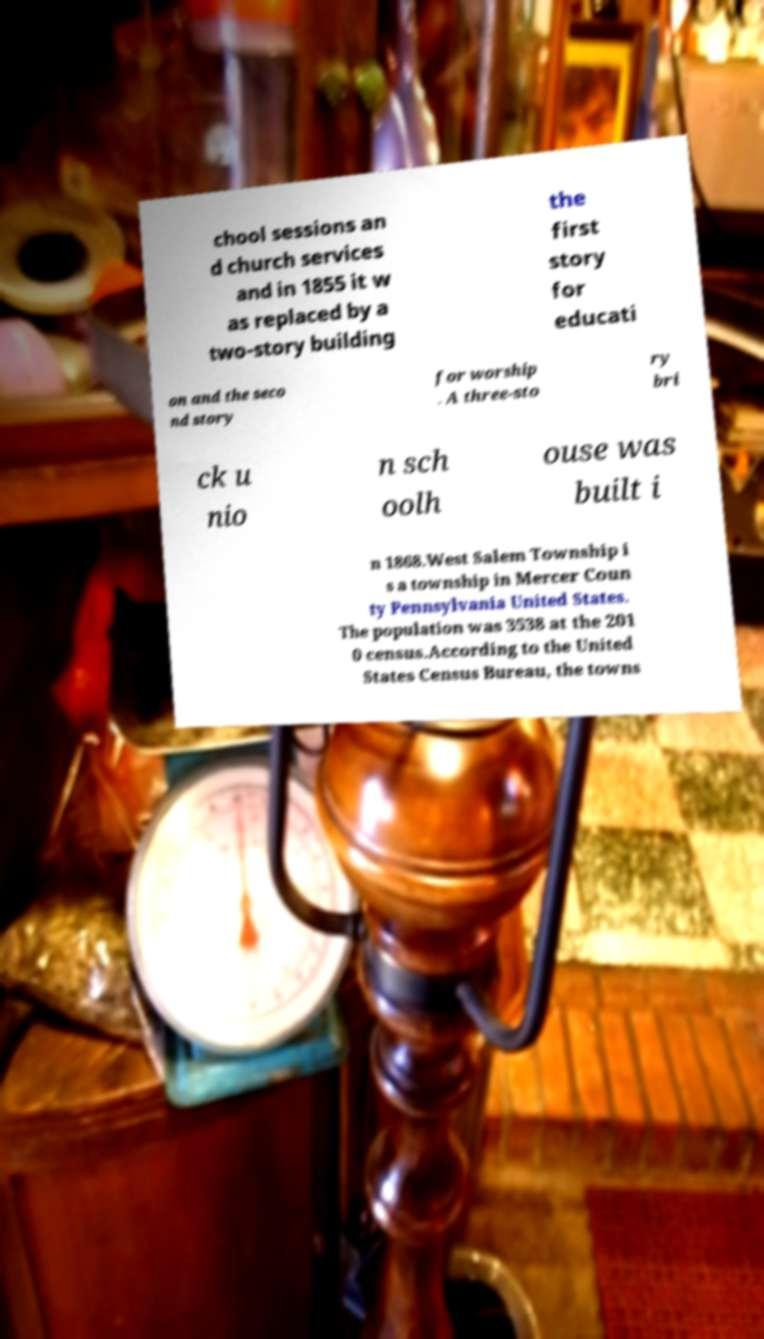I need the written content from this picture converted into text. Can you do that? chool sessions an d church services and in 1855 it w as replaced by a two-story building the first story for educati on and the seco nd story for worship . A three-sto ry bri ck u nio n sch oolh ouse was built i n 1868.West Salem Township i s a township in Mercer Coun ty Pennsylvania United States. The population was 3538 at the 201 0 census.According to the United States Census Bureau, the towns 